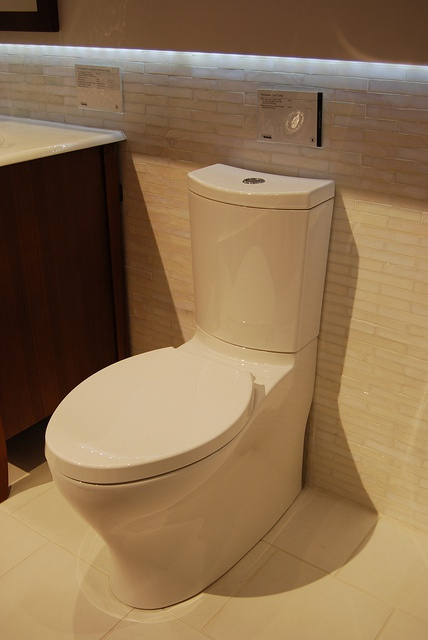Describe the objects in this image and their specific colors. I can see toilet in maroon, olive, and tan tones and sink in maroon, tan, darkgray, and gray tones in this image. 